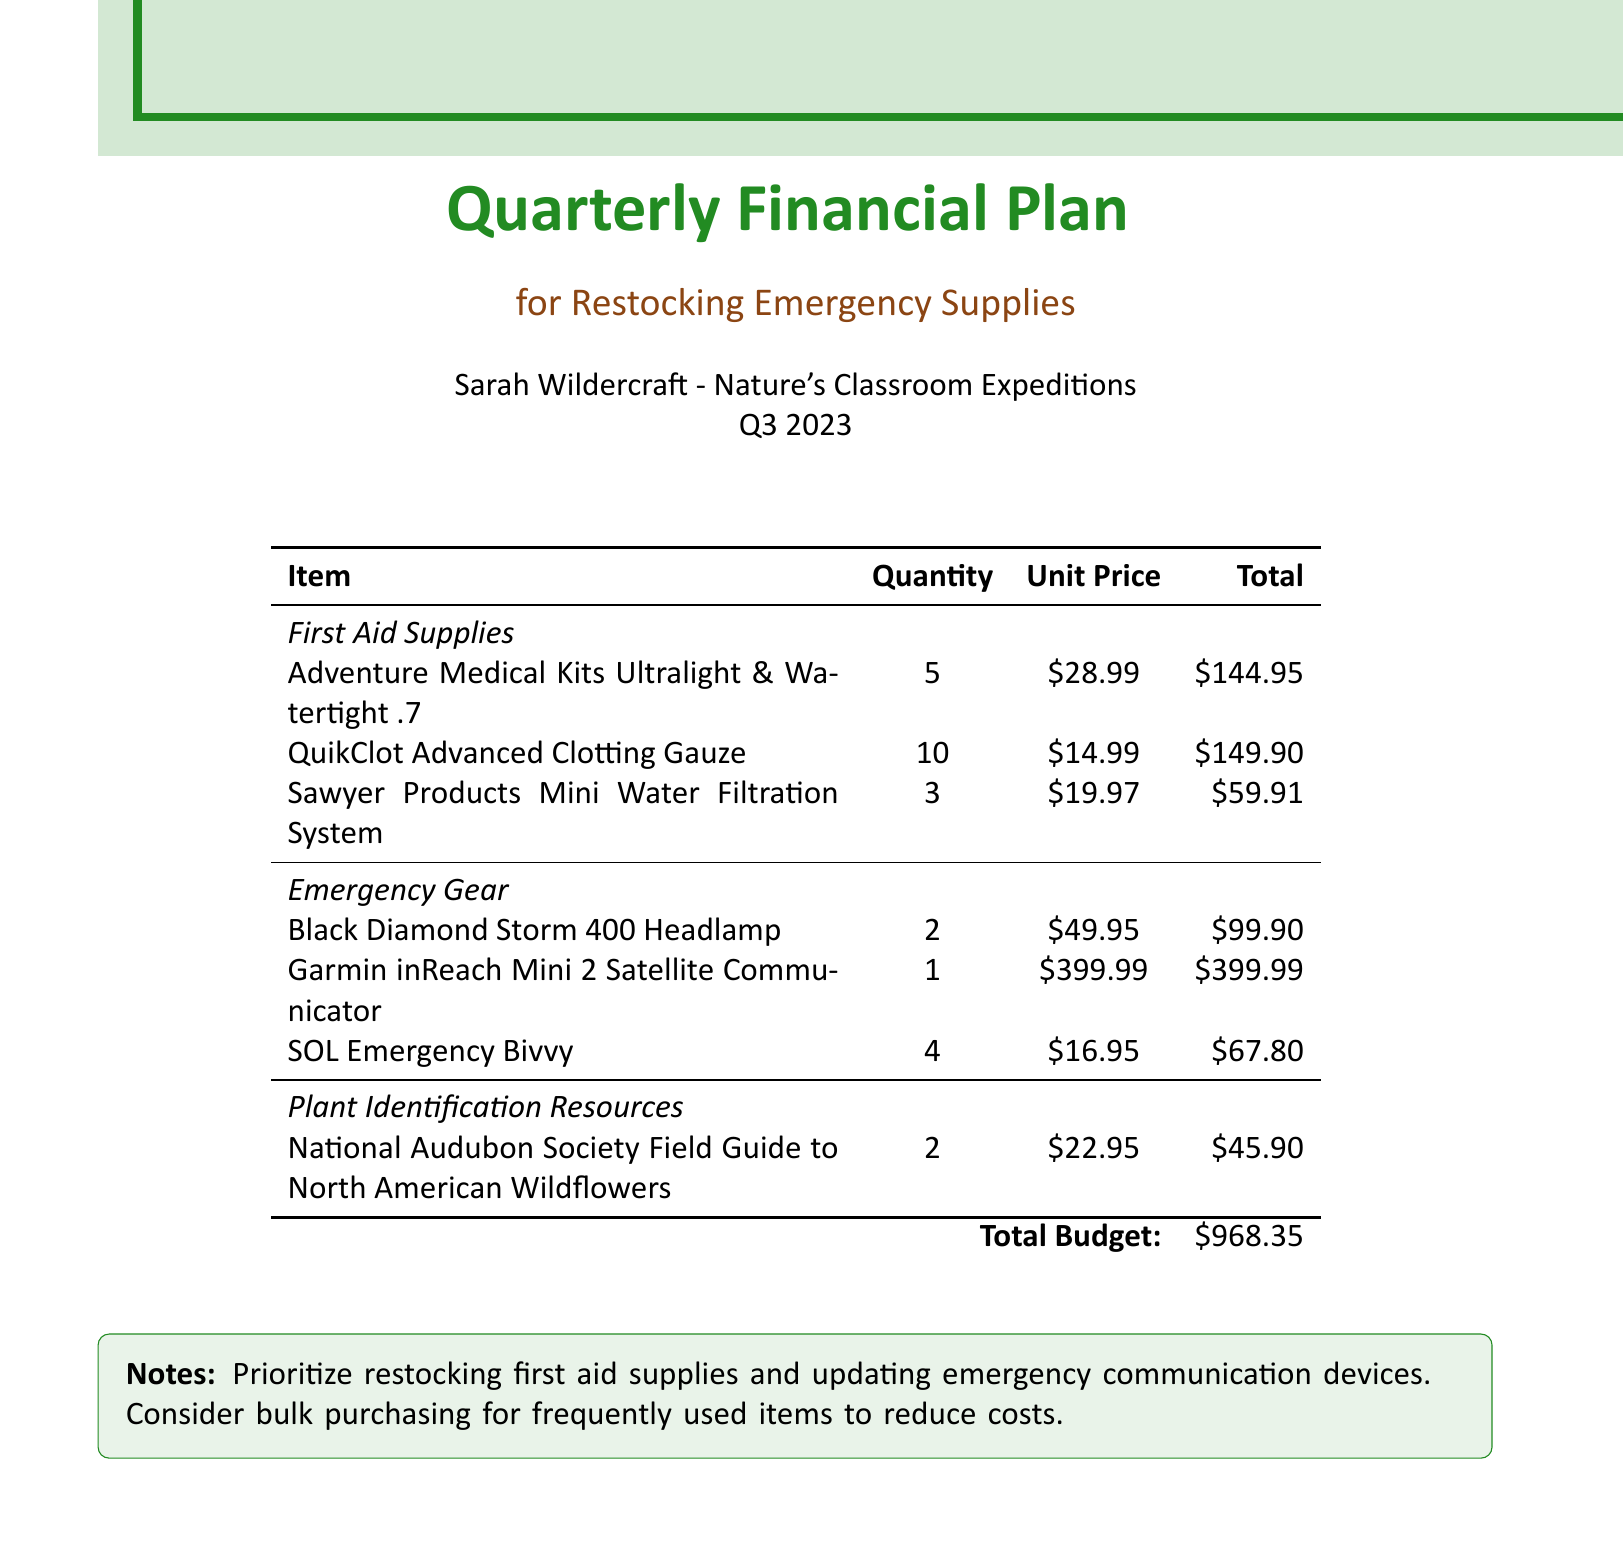What is the total budget? The total budget is the sum of all expenses listed in the document.
Answer: $968.35 How many Adventure Medical Kits are being restocked? The document specifies the quantity of Adventure Medical Kits being purchased.
Answer: 5 What is the unit price of the Garmin inReach Mini 2 Satellite Communicator? This is directly stated in the table under the "Unit Price" column for the Garmin inReach Mini 2 Satellite Communicator.
Answer: $399.99 What does the budget prioritize restocking? The notes section clearly indicates which supplies are prioritized in the restocking effort.
Answer: First aid supplies How many SOL Emergency Bivvies are included in the budget? The document lists the quantity of SOL Emergency Bivvies planned for restocking.
Answer: 4 What is the total cost for the QuikClot Advanced Clotting Gauze? The total cost for QuikClot can be calculated from the quantity and unit price provided in the table.
Answer: $149.90 Which plant identification resource is included in the budget? The document specifies the title of the plant identification resource in the inventory.
Answer: National Audubon Society Field Guide to North American Wildflowers How many Sawyer Products Mini Water Filtration Systems are being purchased? The table states the quantity of the Sawyer Products Mini Water Filtration Systems included in the budget.
Answer: 3 What color is the document's header? The document explicitly mentions the color used for the header text.
Answer: Forest green 